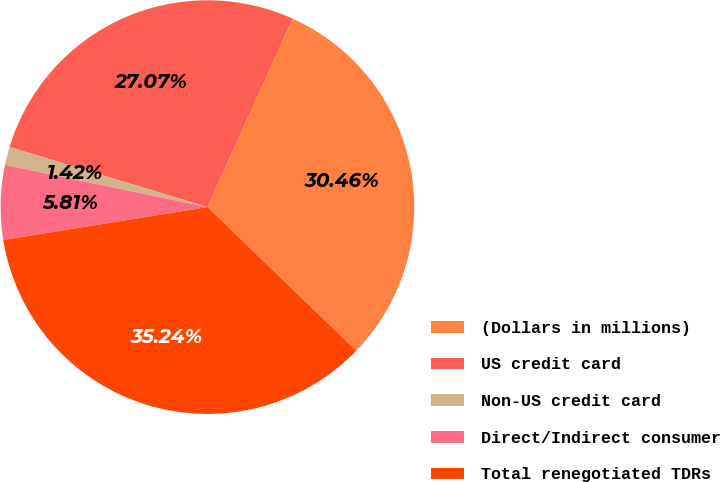Convert chart. <chart><loc_0><loc_0><loc_500><loc_500><pie_chart><fcel>(Dollars in millions)<fcel>US credit card<fcel>Non-US credit card<fcel>Direct/Indirect consumer<fcel>Total renegotiated TDRs<nl><fcel>30.46%<fcel>27.07%<fcel>1.42%<fcel>5.81%<fcel>35.24%<nl></chart> 